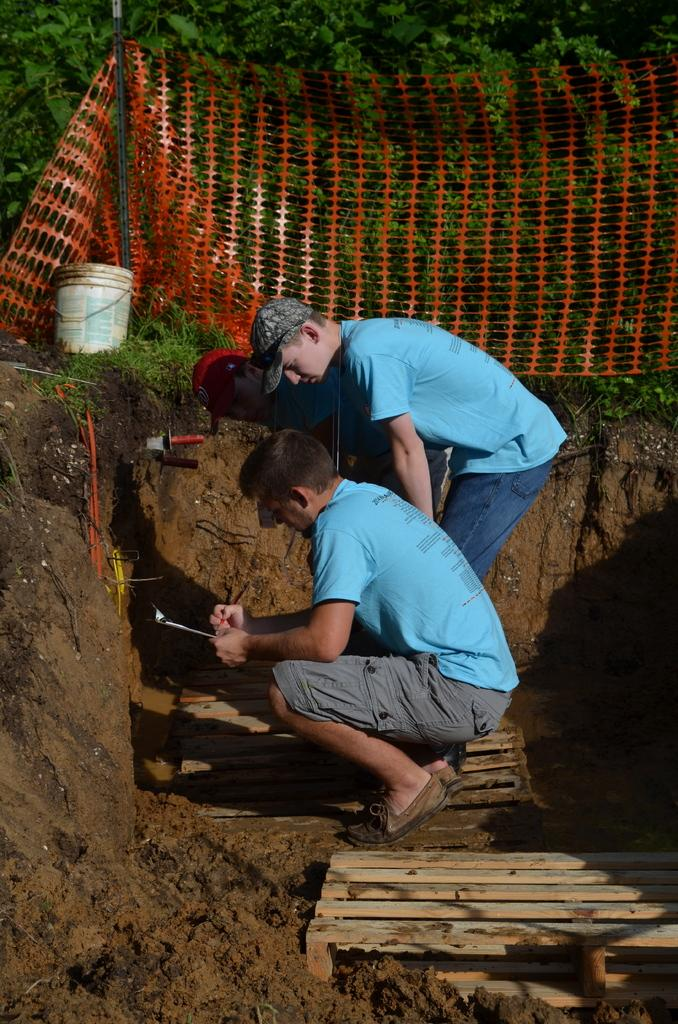What type of vegetation can be seen in the image? There are trees in the image. What is separating the trees from the rest of the image? There is a fence in the image. What object can be seen near the fence? There is a bucket in the image. How many people are present in the image? There are two people in the image, one sitting on the ground and one standing on the ground. What route does the person standing on the ground take in the image? There is no indication of a route or any movement in the image; the person is simply standing on the ground. What record is being set by the person sitting on the ground in the image? There is no record being set in the image; the person is simply sitting on the ground. 